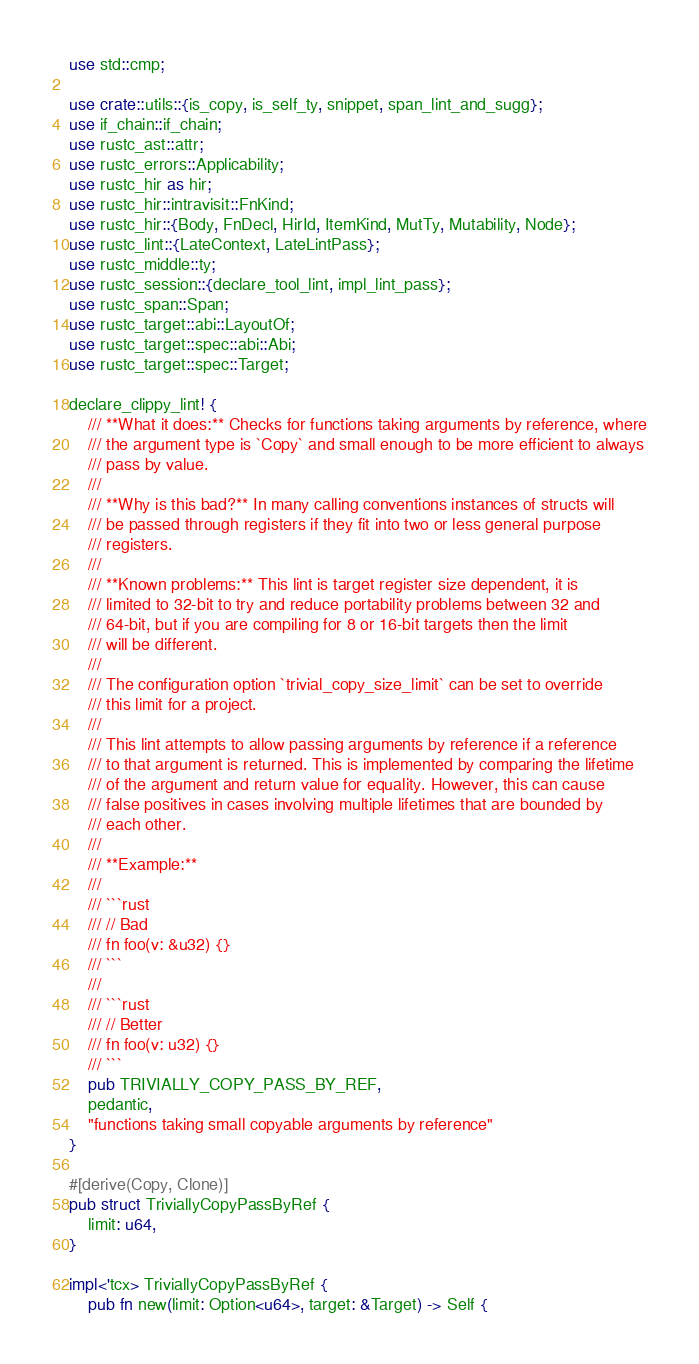Convert code to text. <code><loc_0><loc_0><loc_500><loc_500><_Rust_>use std::cmp;

use crate::utils::{is_copy, is_self_ty, snippet, span_lint_and_sugg};
use if_chain::if_chain;
use rustc_ast::attr;
use rustc_errors::Applicability;
use rustc_hir as hir;
use rustc_hir::intravisit::FnKind;
use rustc_hir::{Body, FnDecl, HirId, ItemKind, MutTy, Mutability, Node};
use rustc_lint::{LateContext, LateLintPass};
use rustc_middle::ty;
use rustc_session::{declare_tool_lint, impl_lint_pass};
use rustc_span::Span;
use rustc_target::abi::LayoutOf;
use rustc_target::spec::abi::Abi;
use rustc_target::spec::Target;

declare_clippy_lint! {
    /// **What it does:** Checks for functions taking arguments by reference, where
    /// the argument type is `Copy` and small enough to be more efficient to always
    /// pass by value.
    ///
    /// **Why is this bad?** In many calling conventions instances of structs will
    /// be passed through registers if they fit into two or less general purpose
    /// registers.
    ///
    /// **Known problems:** This lint is target register size dependent, it is
    /// limited to 32-bit to try and reduce portability problems between 32 and
    /// 64-bit, but if you are compiling for 8 or 16-bit targets then the limit
    /// will be different.
    ///
    /// The configuration option `trivial_copy_size_limit` can be set to override
    /// this limit for a project.
    ///
    /// This lint attempts to allow passing arguments by reference if a reference
    /// to that argument is returned. This is implemented by comparing the lifetime
    /// of the argument and return value for equality. However, this can cause
    /// false positives in cases involving multiple lifetimes that are bounded by
    /// each other.
    ///
    /// **Example:**
    ///
    /// ```rust
    /// // Bad
    /// fn foo(v: &u32) {}
    /// ```
    ///
    /// ```rust
    /// // Better
    /// fn foo(v: u32) {}
    /// ```
    pub TRIVIALLY_COPY_PASS_BY_REF,
    pedantic,
    "functions taking small copyable arguments by reference"
}

#[derive(Copy, Clone)]
pub struct TriviallyCopyPassByRef {
    limit: u64,
}

impl<'tcx> TriviallyCopyPassByRef {
    pub fn new(limit: Option<u64>, target: &Target) -> Self {</code> 